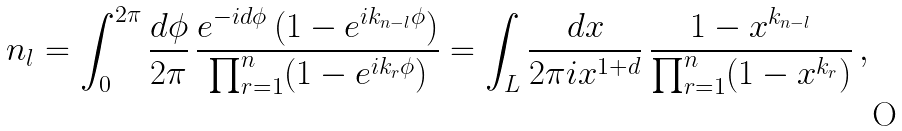<formula> <loc_0><loc_0><loc_500><loc_500>n _ { l } = \int _ { 0 } ^ { 2 \pi } \frac { d \phi } { 2 \pi } \, \frac { e ^ { - i d \phi } \, ( 1 - e ^ { i k _ { n - l } \phi } ) } { \prod _ { r = 1 } ^ { n } ( 1 - e ^ { i k _ { r } \phi } ) } = \int _ { L } \frac { d x } { 2 \pi i x ^ { 1 + d } } \, \frac { 1 - x ^ { k _ { n - l } } } { \prod _ { r = 1 } ^ { n } ( 1 - x ^ { k _ { r } } ) } \, ,</formula> 